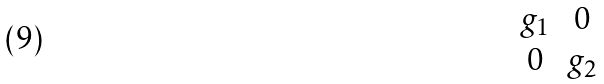Convert formula to latex. <formula><loc_0><loc_0><loc_500><loc_500>\begin{matrix} g _ { 1 } & 0 \\ 0 & g _ { 2 } \end{matrix}</formula> 